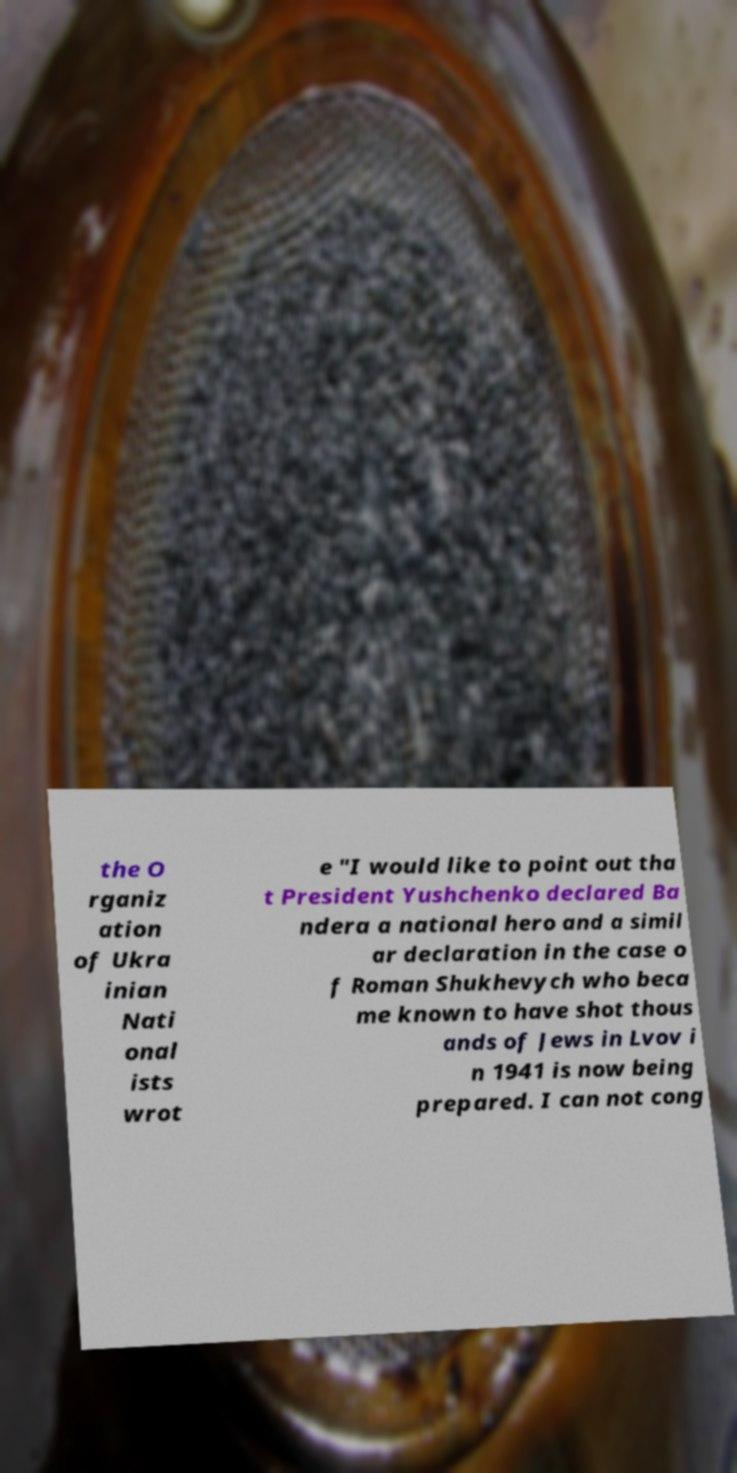Could you extract and type out the text from this image? the O rganiz ation of Ukra inian Nati onal ists wrot e "I would like to point out tha t President Yushchenko declared Ba ndera a national hero and a simil ar declaration in the case o f Roman Shukhevych who beca me known to have shot thous ands of Jews in Lvov i n 1941 is now being prepared. I can not cong 